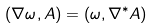<formula> <loc_0><loc_0><loc_500><loc_500>( \nabla \omega , A ) = ( \omega , \nabla ^ { * } A )</formula> 